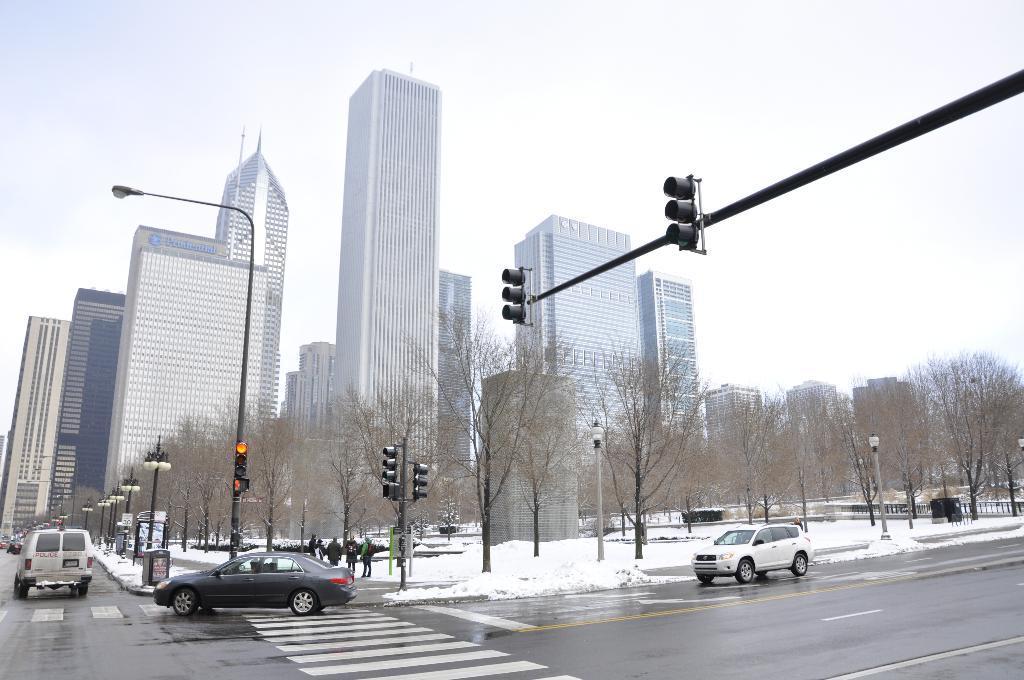Please provide a concise description of this image. In this picture I can see few vehicles and the snow in the middle. There are trees and lights, in the background I can see few buildings, at the top there is the sky. 